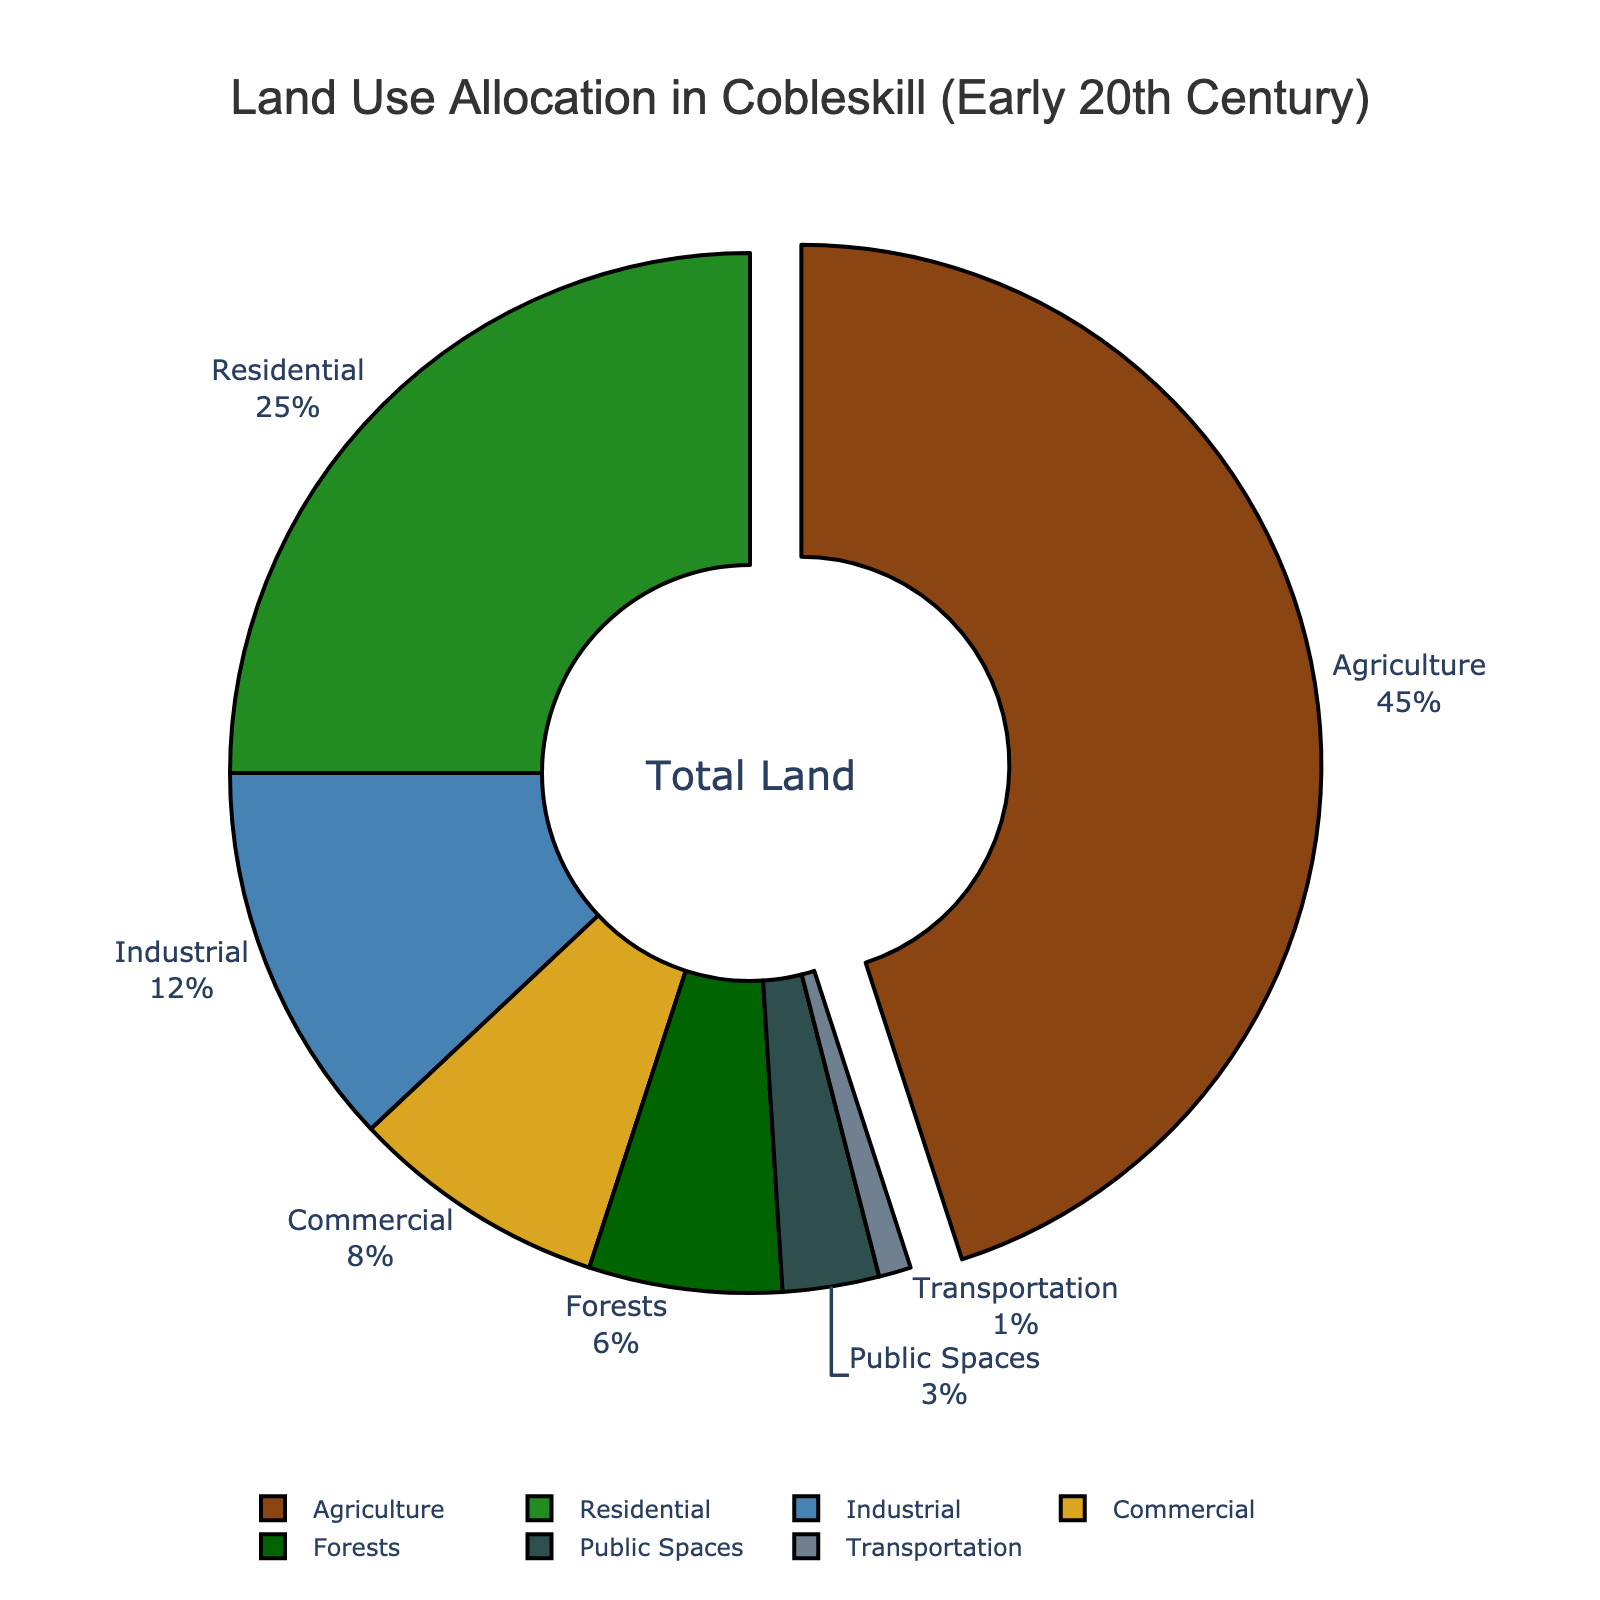What's the largest land use type represented in the chart? The chart shows the distribution of various land use types. Agriculture occupies the largest portion, which is visually the biggest segment in the pie chart.
Answer: Agriculture Which land use type has the smallest allocation? By examining the segments, the smallest slice corresponds to transportation.
Answer: Transportation What is the combined percentage of industrial and commercial land use? From the pie chart, industrial land use is 12% and commercial land use is 8%. Therefore, their combined percentage is 12% + 8% = 20%.
Answer: 20% Which land use types are represented in green? The segments in shades of green represent residential and forests.
Answer: Residential and Forests Is the percentage of residential land use greater than that of industrial and commercial combined? Residential land use is 25%, while industrial (12%) and commercial (8%) combined make 12% + 8% = 20%. Since 25% is greater than 20%, residential land use has a higher percentage.
Answer: Yes What's the difference in percentage between agriculture and residential land use? Agriculture is 45%, and residential is 25%. The difference is 45% - 25% = 20%.
Answer: 20% What is the ratio of public spaces to forests in terms of land use percentage? Public spaces have 3%, and forests have 6%. The ratio is 3%/6% = 1/2.
Answer: 1:2 Does commercial or public spaces have a higher percentage allocation? Commercial land use is 8%, while public spaces are 3%. Since 8% is greater than 3%, commercial has a higher percentage allocation.
Answer: Commercial Combining the land use percentages for commercial, public spaces, and transportation, does it exceed 15%? Adding the percentages, commercial (8%) + public spaces (3%) + transportation (1%) results in 8% + 3% + 1% = 12%. Since 12% is less than 15%, the combined allocation does not exceed 15%.
Answer: No 